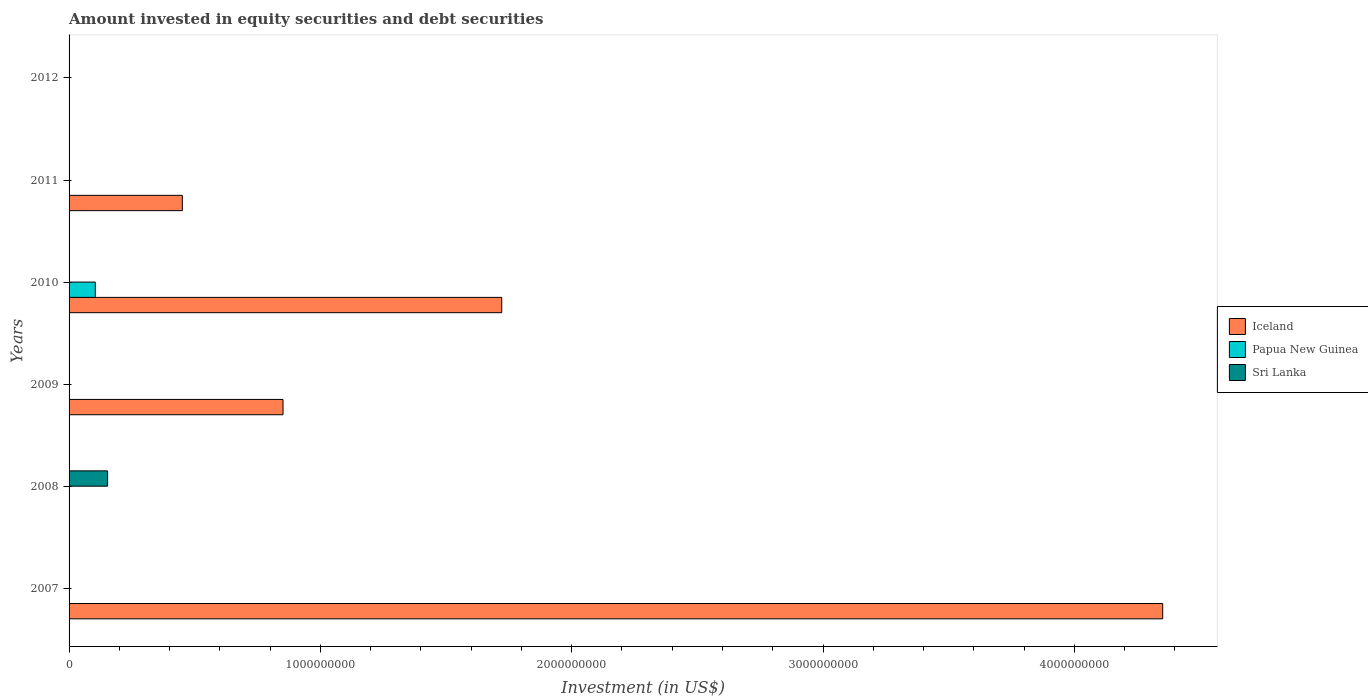Are the number of bars per tick equal to the number of legend labels?
Ensure brevity in your answer.  No. How many bars are there on the 2nd tick from the top?
Ensure brevity in your answer.  1. How many bars are there on the 1st tick from the bottom?
Ensure brevity in your answer.  1. What is the label of the 3rd group of bars from the top?
Keep it short and to the point. 2010. Across all years, what is the maximum amount invested in equity securities and debt securities in Papua New Guinea?
Provide a succinct answer. 1.04e+08. Across all years, what is the minimum amount invested in equity securities and debt securities in Sri Lanka?
Keep it short and to the point. 0. What is the total amount invested in equity securities and debt securities in Sri Lanka in the graph?
Make the answer very short. 1.53e+08. What is the difference between the amount invested in equity securities and debt securities in Iceland in 2009 and the amount invested in equity securities and debt securities in Sri Lanka in 2008?
Your answer should be compact. 6.98e+08. What is the average amount invested in equity securities and debt securities in Sri Lanka per year?
Offer a very short reply. 2.56e+07. What is the ratio of the amount invested in equity securities and debt securities in Iceland in 2009 to that in 2011?
Give a very brief answer. 1.89. What is the difference between the highest and the lowest amount invested in equity securities and debt securities in Iceland?
Ensure brevity in your answer.  4.35e+09. In how many years, is the amount invested in equity securities and debt securities in Iceland greater than the average amount invested in equity securities and debt securities in Iceland taken over all years?
Make the answer very short. 2. Are all the bars in the graph horizontal?
Your response must be concise. Yes. How many years are there in the graph?
Provide a short and direct response. 6. What is the difference between two consecutive major ticks on the X-axis?
Your answer should be compact. 1.00e+09. Are the values on the major ticks of X-axis written in scientific E-notation?
Your answer should be compact. No. Does the graph contain any zero values?
Ensure brevity in your answer.  Yes. Does the graph contain grids?
Offer a terse response. No. Where does the legend appear in the graph?
Your response must be concise. Center right. What is the title of the graph?
Give a very brief answer. Amount invested in equity securities and debt securities. What is the label or title of the X-axis?
Offer a very short reply. Investment (in US$). What is the label or title of the Y-axis?
Your answer should be very brief. Years. What is the Investment (in US$) of Iceland in 2007?
Keep it short and to the point. 4.35e+09. What is the Investment (in US$) of Papua New Guinea in 2007?
Offer a very short reply. 0. What is the Investment (in US$) in Iceland in 2008?
Keep it short and to the point. 0. What is the Investment (in US$) of Sri Lanka in 2008?
Offer a terse response. 1.53e+08. What is the Investment (in US$) in Iceland in 2009?
Keep it short and to the point. 8.51e+08. What is the Investment (in US$) in Iceland in 2010?
Keep it short and to the point. 1.72e+09. What is the Investment (in US$) in Papua New Guinea in 2010?
Offer a terse response. 1.04e+08. What is the Investment (in US$) in Iceland in 2011?
Offer a very short reply. 4.51e+08. What is the Investment (in US$) of Iceland in 2012?
Provide a short and direct response. 0. Across all years, what is the maximum Investment (in US$) of Iceland?
Ensure brevity in your answer.  4.35e+09. Across all years, what is the maximum Investment (in US$) in Papua New Guinea?
Your answer should be compact. 1.04e+08. Across all years, what is the maximum Investment (in US$) of Sri Lanka?
Ensure brevity in your answer.  1.53e+08. What is the total Investment (in US$) of Iceland in the graph?
Provide a short and direct response. 7.38e+09. What is the total Investment (in US$) in Papua New Guinea in the graph?
Provide a succinct answer. 1.04e+08. What is the total Investment (in US$) in Sri Lanka in the graph?
Provide a succinct answer. 1.53e+08. What is the difference between the Investment (in US$) of Iceland in 2007 and that in 2009?
Your answer should be compact. 3.50e+09. What is the difference between the Investment (in US$) in Iceland in 2007 and that in 2010?
Keep it short and to the point. 2.63e+09. What is the difference between the Investment (in US$) in Iceland in 2007 and that in 2011?
Make the answer very short. 3.90e+09. What is the difference between the Investment (in US$) in Iceland in 2009 and that in 2010?
Your response must be concise. -8.70e+08. What is the difference between the Investment (in US$) of Iceland in 2009 and that in 2011?
Keep it short and to the point. 4.01e+08. What is the difference between the Investment (in US$) in Iceland in 2010 and that in 2011?
Make the answer very short. 1.27e+09. What is the difference between the Investment (in US$) of Iceland in 2007 and the Investment (in US$) of Sri Lanka in 2008?
Ensure brevity in your answer.  4.20e+09. What is the difference between the Investment (in US$) of Iceland in 2007 and the Investment (in US$) of Papua New Guinea in 2010?
Offer a terse response. 4.25e+09. What is the difference between the Investment (in US$) in Iceland in 2009 and the Investment (in US$) in Papua New Guinea in 2010?
Offer a very short reply. 7.47e+08. What is the average Investment (in US$) in Iceland per year?
Your answer should be very brief. 1.23e+09. What is the average Investment (in US$) of Papua New Guinea per year?
Give a very brief answer. 1.74e+07. What is the average Investment (in US$) in Sri Lanka per year?
Your answer should be compact. 2.56e+07. In the year 2010, what is the difference between the Investment (in US$) in Iceland and Investment (in US$) in Papua New Guinea?
Offer a terse response. 1.62e+09. What is the ratio of the Investment (in US$) of Iceland in 2007 to that in 2009?
Offer a terse response. 5.11. What is the ratio of the Investment (in US$) in Iceland in 2007 to that in 2010?
Your response must be concise. 2.53. What is the ratio of the Investment (in US$) in Iceland in 2007 to that in 2011?
Offer a very short reply. 9.65. What is the ratio of the Investment (in US$) in Iceland in 2009 to that in 2010?
Make the answer very short. 0.49. What is the ratio of the Investment (in US$) in Iceland in 2009 to that in 2011?
Your answer should be compact. 1.89. What is the ratio of the Investment (in US$) in Iceland in 2010 to that in 2011?
Keep it short and to the point. 3.82. What is the difference between the highest and the second highest Investment (in US$) in Iceland?
Make the answer very short. 2.63e+09. What is the difference between the highest and the lowest Investment (in US$) of Iceland?
Provide a short and direct response. 4.35e+09. What is the difference between the highest and the lowest Investment (in US$) in Papua New Guinea?
Provide a short and direct response. 1.04e+08. What is the difference between the highest and the lowest Investment (in US$) in Sri Lanka?
Offer a very short reply. 1.53e+08. 